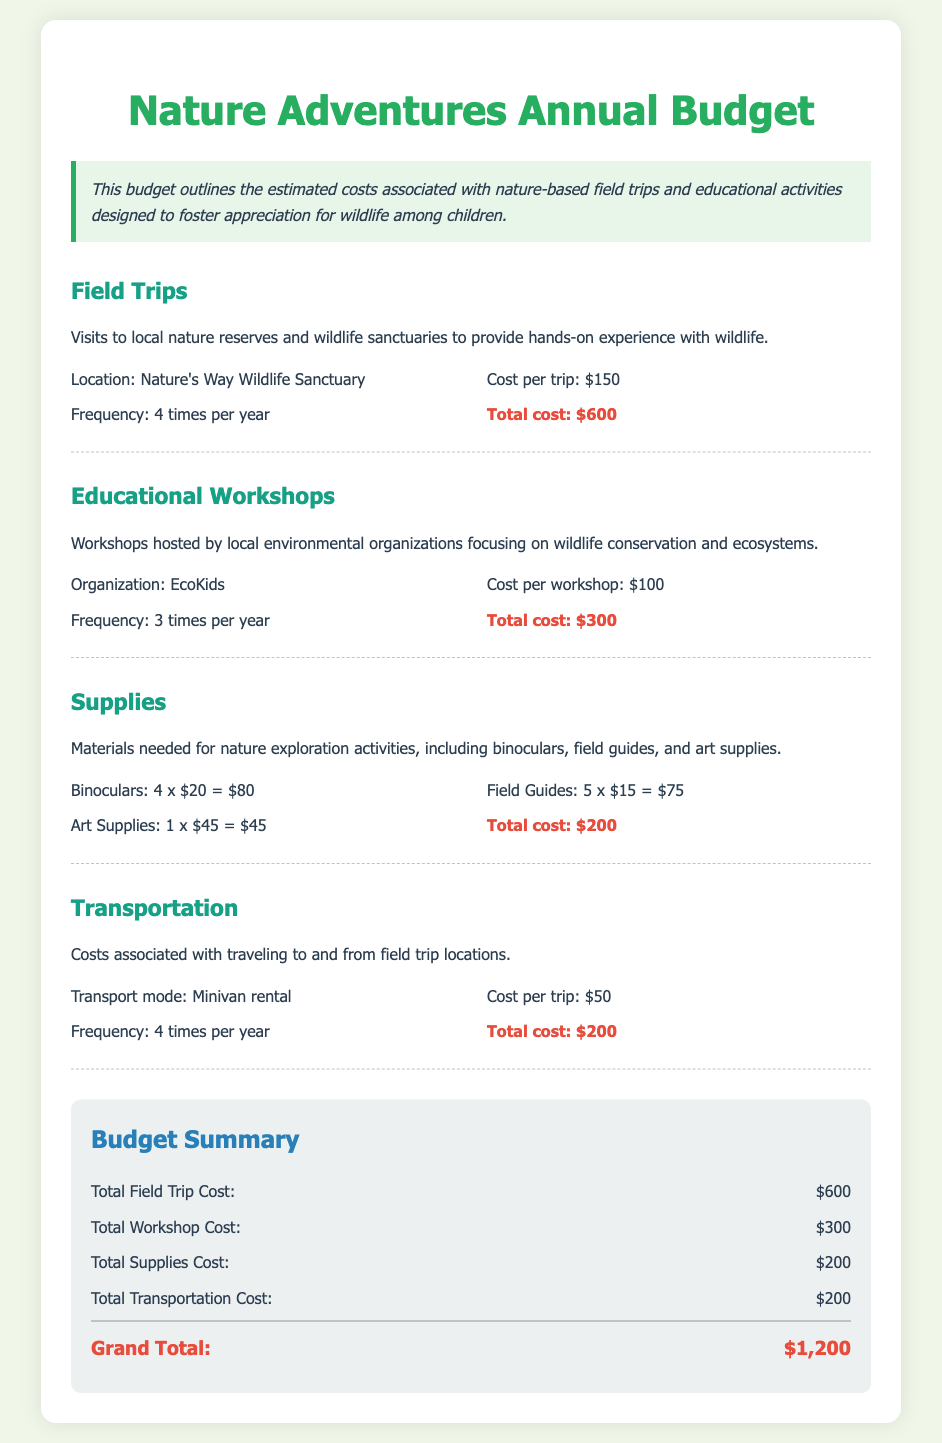What is the total cost for field trips? The total cost for field trips is detailed under the Field Trips section and is $600.
Answer: $600 How many educational workshops will be held each year? The frequency of educational workshops listed is 3 times per year.
Answer: 3 What is the cost per workshop hosted by EcoKids? The cost per workshop is specified as $100 in the Educational Workshops section.
Answer: $100 What is included in supplies? The supplies include binoculars, field guides, and art supplies as detailed in the Supplies section.
Answer: Binoculars, field guides, art supplies How much is budgeted for transportation costs? The total transportation cost can be found in the Transportation section, which indicates it is $200.
Answer: $200 What is the total estimated budget for the year? The grand total summarizes all budget items and amounts to $1,200.
Answer: $1,200 How often will field trips occur? The frequency of the field trips is stated as 4 times per year.
Answer: 4 times What is the cost of binoculars included in supplies? The cost of binoculars is detailed as 4 x $20, totaling $80.
Answer: $80 Which organization is hosting the educational workshops? The organization mentioned for hosting the workshops is EcoKids.
Answer: EcoKids 